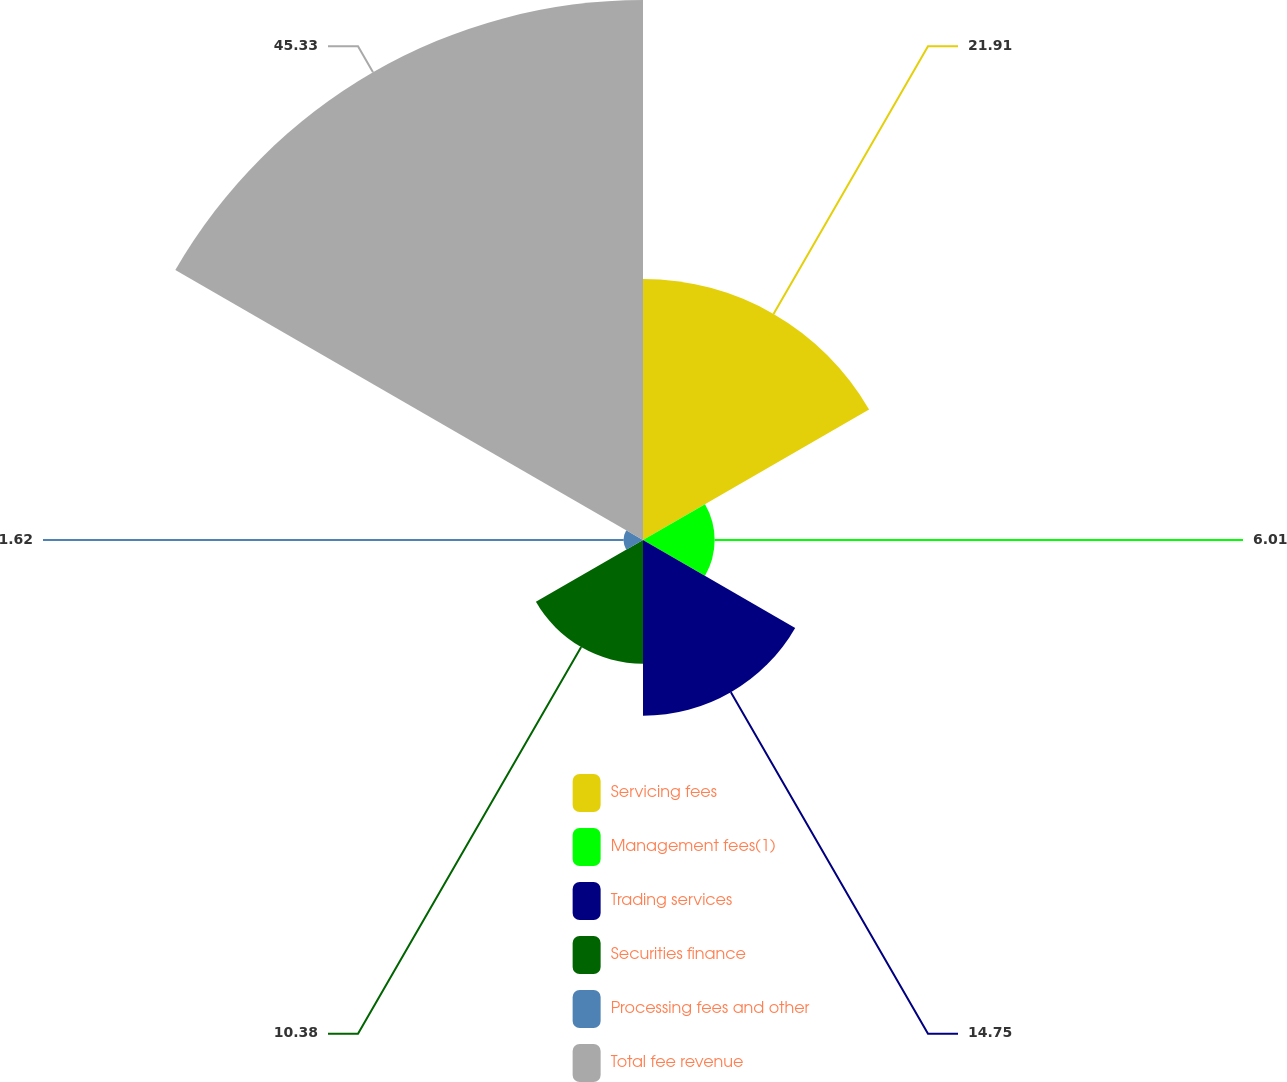Convert chart to OTSL. <chart><loc_0><loc_0><loc_500><loc_500><pie_chart><fcel>Servicing fees<fcel>Management fees(1)<fcel>Trading services<fcel>Securities finance<fcel>Processing fees and other<fcel>Total fee revenue<nl><fcel>21.91%<fcel>6.01%<fcel>14.75%<fcel>10.38%<fcel>1.62%<fcel>45.32%<nl></chart> 